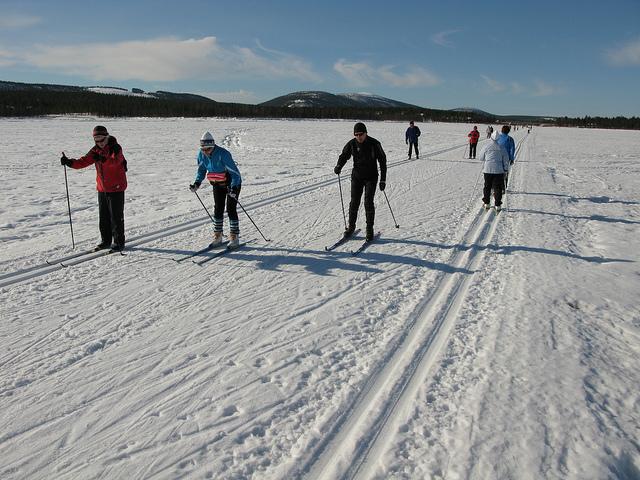What are the people doing?
Answer briefly. Skiing. Is this a sunny photo?
Be succinct. Yes. Is this a cold day?
Answer briefly. Yes. How far are the people from other people?
Keep it brief. 25 feet. 